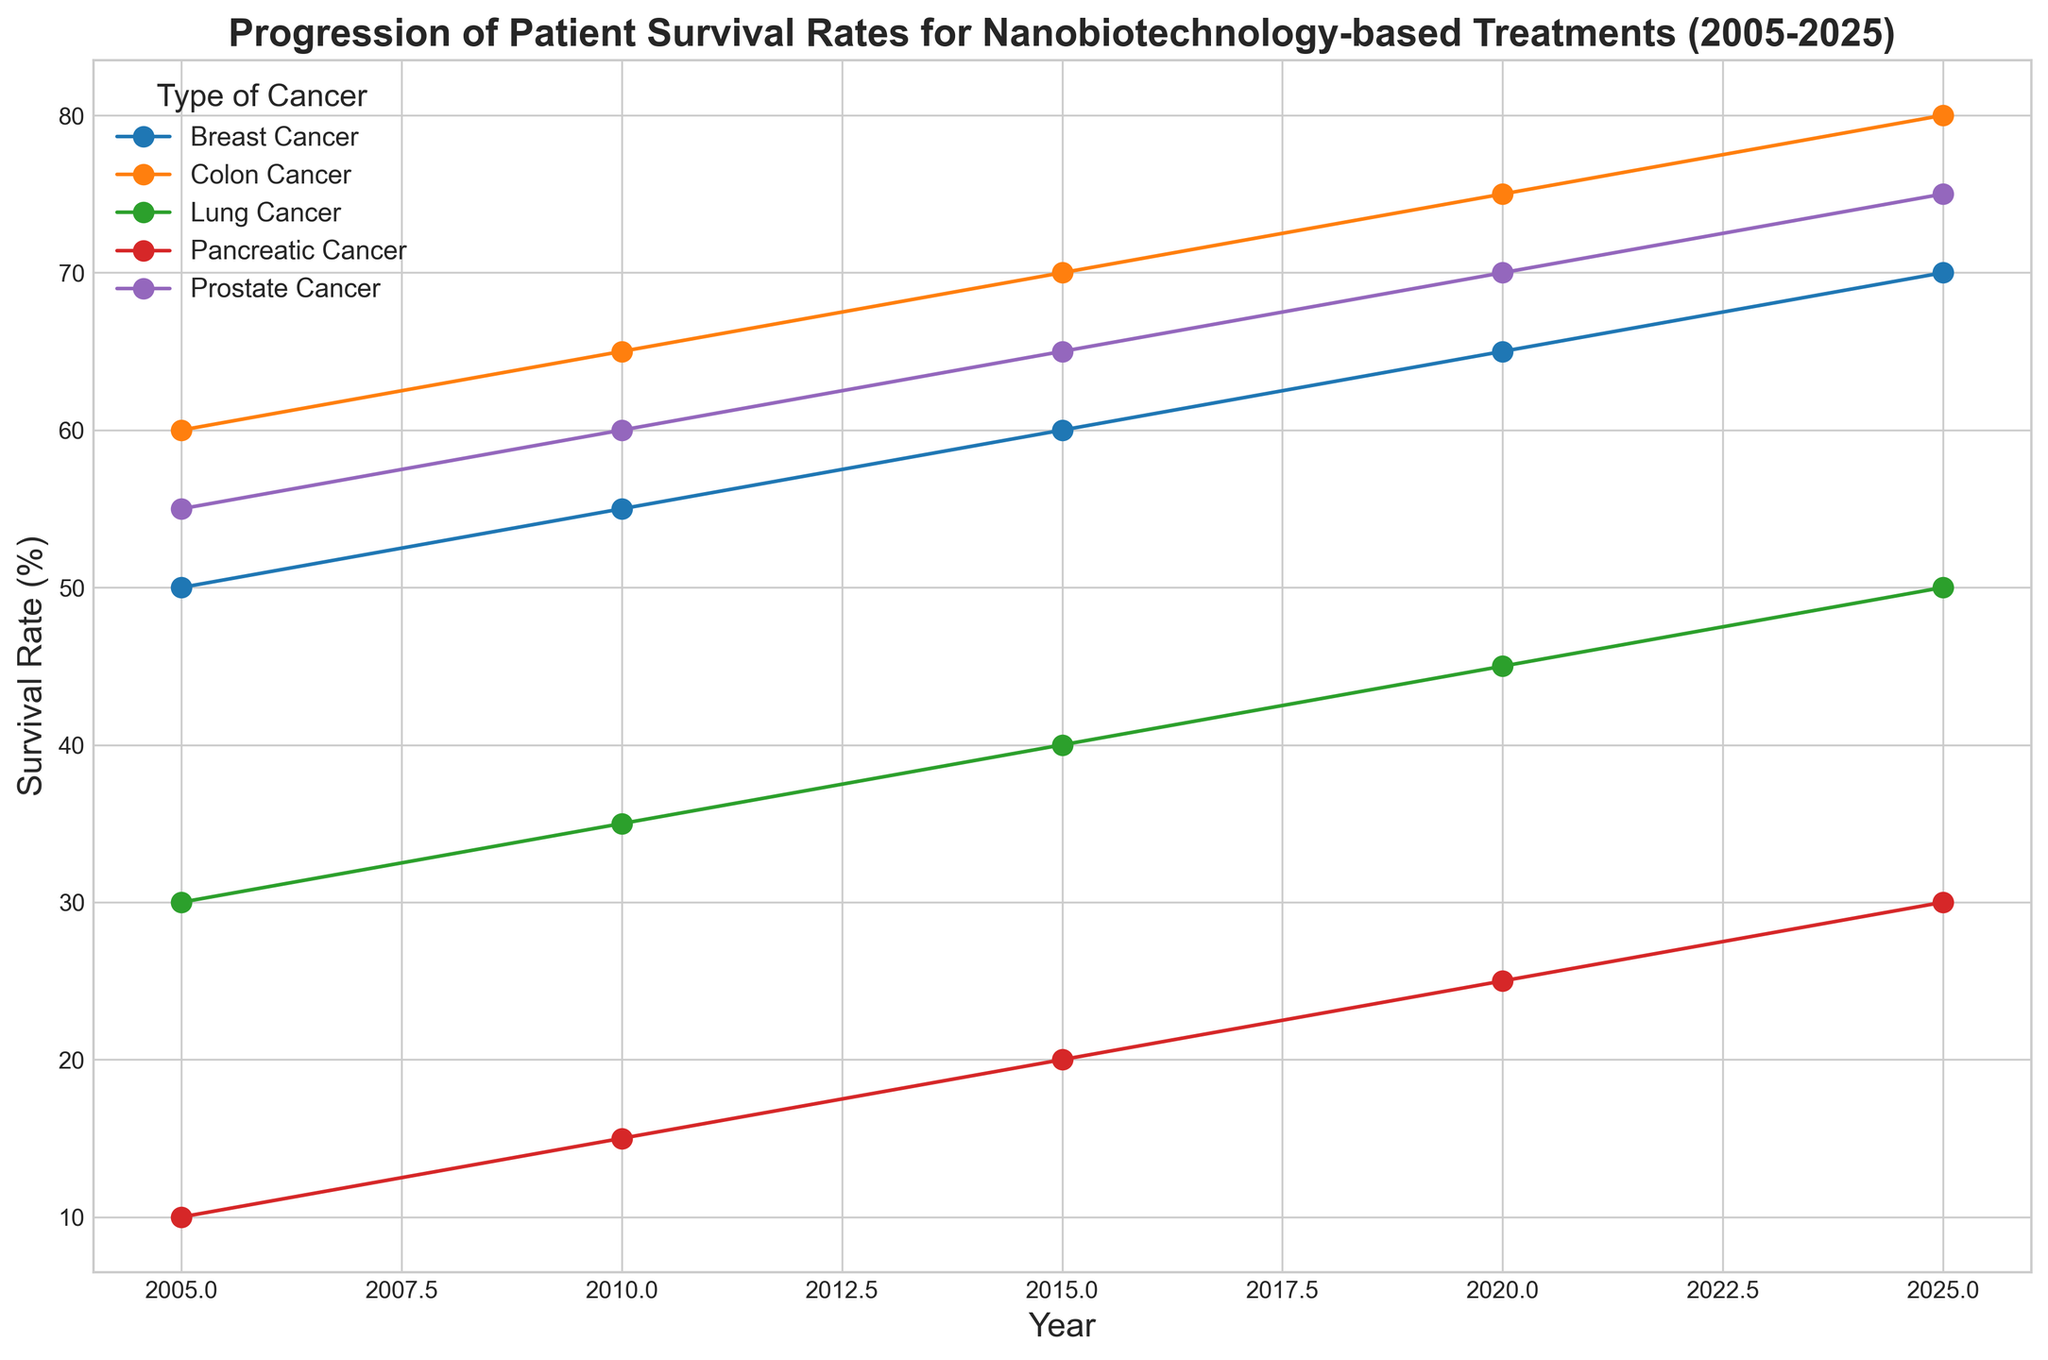What is the survival rate for breast cancer in 2025? The plot shows the yearly progression of patient survival rates for different types of cancer treated with nanobiotechnology. To find the survival rate for breast cancer in 2025, locate the data point corresponding to breast cancer on the line chart for the year 2025.
Answer: 70% How did lung cancer survival rates change from 2005 to 2025? To determine the change in survival rates, find the survival rates for lung cancer in 2005 and 2025 on the plot. Subtract the 2005 value from the 2025 value. The survival rates are 30% in 2005 and 50% in 2025. So the change is 50% - 30%.
Answer: +20% Which type of cancer showed the most significant increase in survival rate from 2005 to 2025? To answer this, observe all the cancer types on the plot and compare the differences between their 2005 and 2025 survival rates. Calculate the increase by subtracting each 2005 rate from its 2025 counterpart. Pancreatic cancer, with a rise from 10% to 30%, shows the most significant increase (+20%).
Answer: Pancreatic cancer What is the average survival rate across all types of cancer in 2025? To find the average survival rate for all cancers in 2025, add the survival rates of all types for that year and then divide by the number of types (5). The rates are: 70 (Breast) + 50 (Lung) + 75 (Prostate) + 30 (Pancreatic) + 80 (Colon) = 305. Dividing by 5 gives 305/5.
Answer: 61% Which cancer type has the lowest survival rate in 2010, and what is that rate? Examine the survival rates for all cancer types in 2010 by referencing the plot. Compare these values to identify the lowest one. The lowest survival rate in 2010 is 15% for pancreatic cancer.
Answer: Pancreatic cancer, 15% Compare the survival rates of prostate cancer and colon cancer in 2020. Which one is higher and by how much? Find and compare the survival rates for prostate cancer and colon cancer in 2020 on the plot. The rates are 70% for prostate cancer and 75% for colon cancer. Subtract the prostate cancer rate from the colon cancer rate: 75% - 70%.
Answer: Colon cancer by 5% How does the survival rate trend for breast cancer from 2005 to 2025 visually appear? From the plot, identify the breast cancer line and observe its trajectory from 2005 to 2025. Notice that it consistently increases over the years: it starts at 50% in 2005 and reaches 70% in 2025, indicating a steady upwards trend.
Answer: Steadily increasing What is the combined survival rate for lung cancer and pancreatic cancer in 2015? Determine the survival rates for lung cancer and pancreatic cancer in 2015 by looking at the plot. Sum them up. The lung cancer rate is 40%, and the pancreatic cancer rate is 20%. So, 40% + 20%.
Answer: 60% In which year did the survival rate for colon cancer exceed 70%? Observe the plot and track the survival rate line for colon cancer. Identify the first year it exceeds 70%. The colon cancer line crosses 70% between 2015 and 2020.
Answer: 2020 